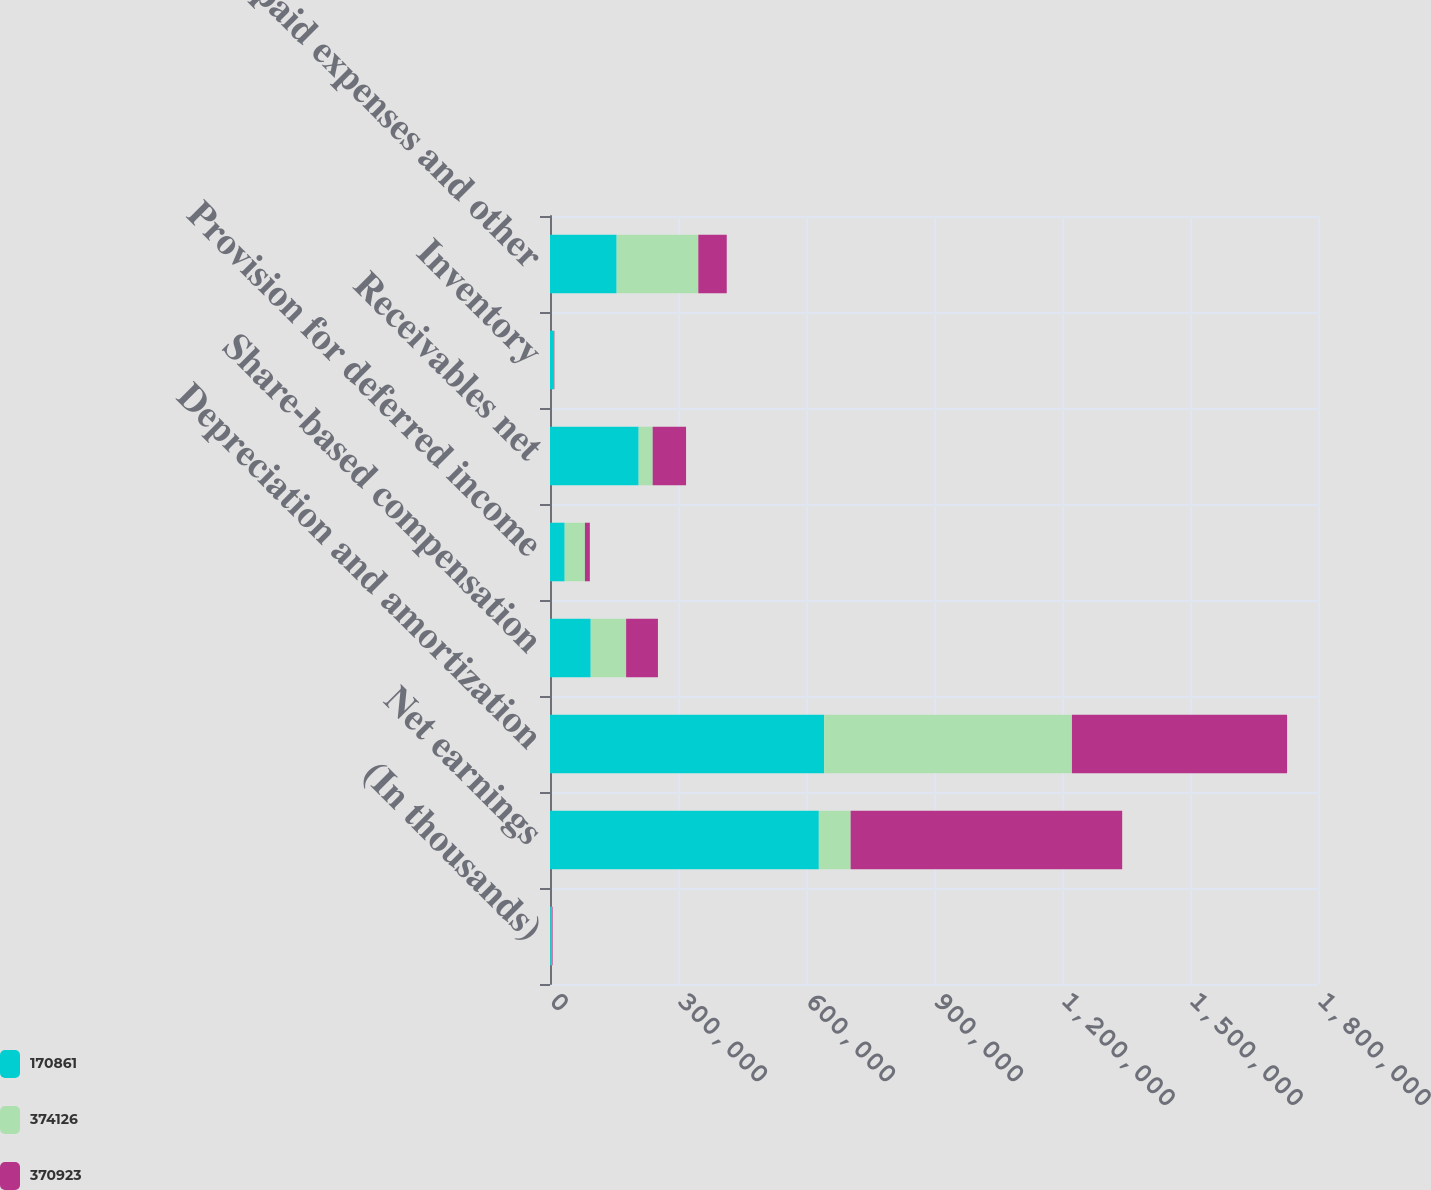Convert chart to OTSL. <chart><loc_0><loc_0><loc_500><loc_500><stacked_bar_chart><ecel><fcel>(In thousands)<fcel>Net earnings<fcel>Depreciation and amortization<fcel>Share-based compensation<fcel>Provision for deferred income<fcel>Receivables net<fcel>Inventory<fcel>Prepaid expenses and other<nl><fcel>170861<fcel>2018<fcel>630059<fcel>642591<fcel>95423<fcel>34428<fcel>207785<fcel>9307<fcel>156216<nl><fcel>374126<fcel>2017<fcel>74536<fcel>580723<fcel>83019<fcel>47409<fcel>32836<fcel>972<fcel>191369<nl><fcel>370923<fcel>2016<fcel>636484<fcel>504236<fcel>74536<fcel>11517<fcel>78258<fcel>666<fcel>66658<nl></chart> 